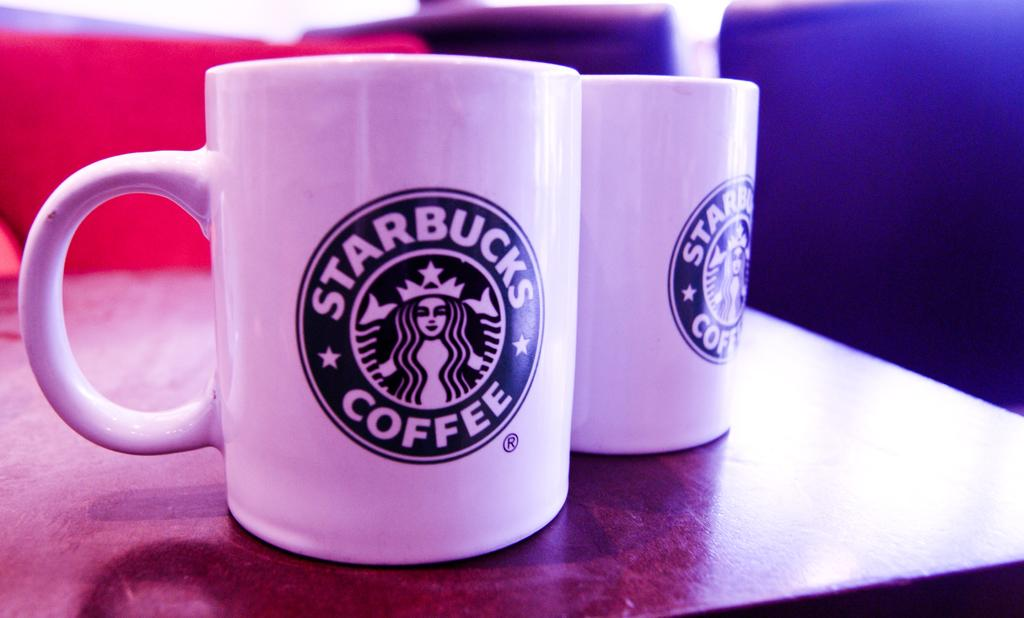<image>
Create a compact narrative representing the image presented. Two ceramic coffee mugs with the Starbucks logo sit on a wooden table. 